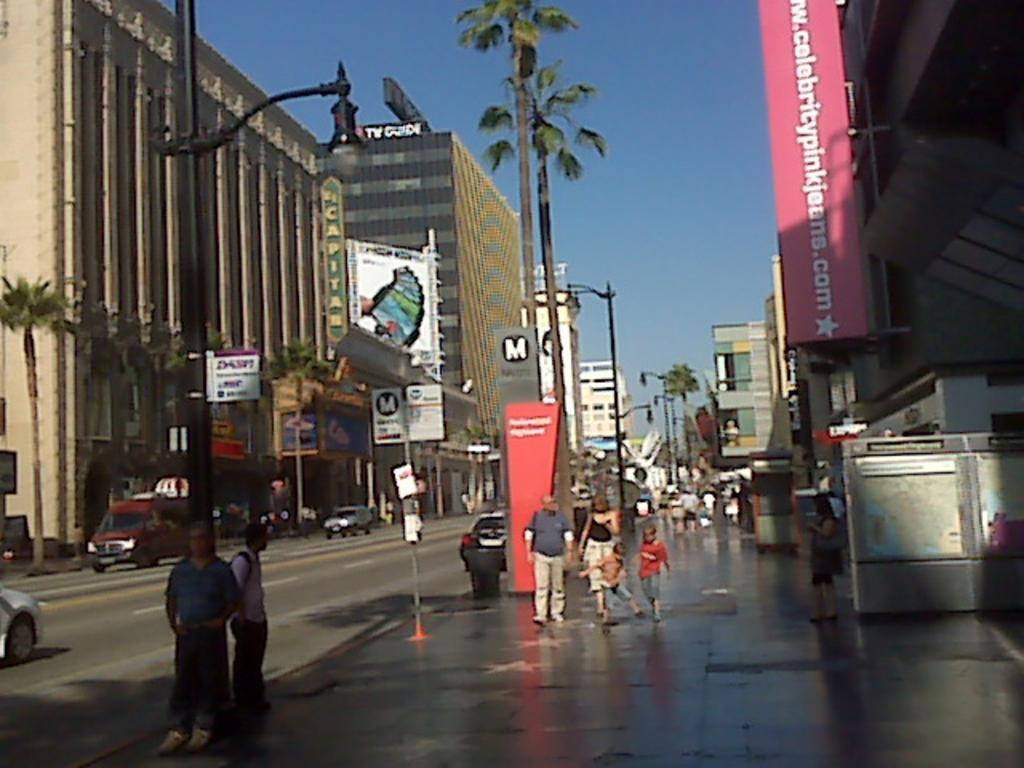Provide a one-sentence caption for the provided image. Palm trees and a banner with Celebritypinkjeans.com are seen near many pedestrians. 